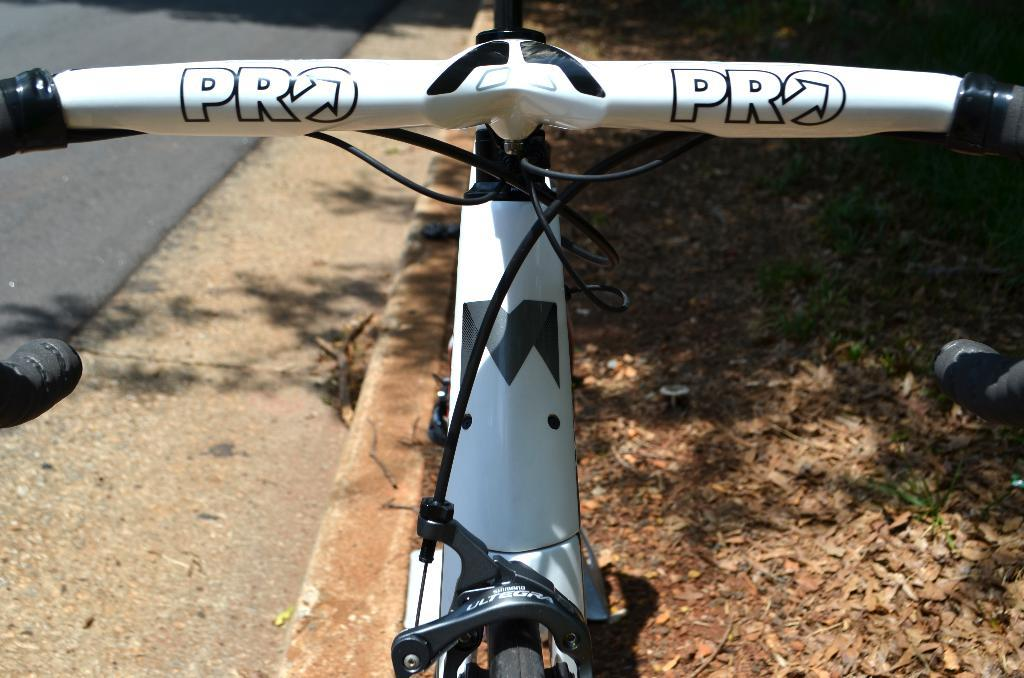What is the main object in the middle of the image? There is a cycle in the middle of the image. What can be seen on the left side of the image? There is a road on the left side of the image. What type of waves can be seen crashing on the shore in the image? There are no waves or shore visible in the image; it features a cycle and a road. How does the jar contribute to the digestion process in the image? There is no jar or reference to digestion in the image. 